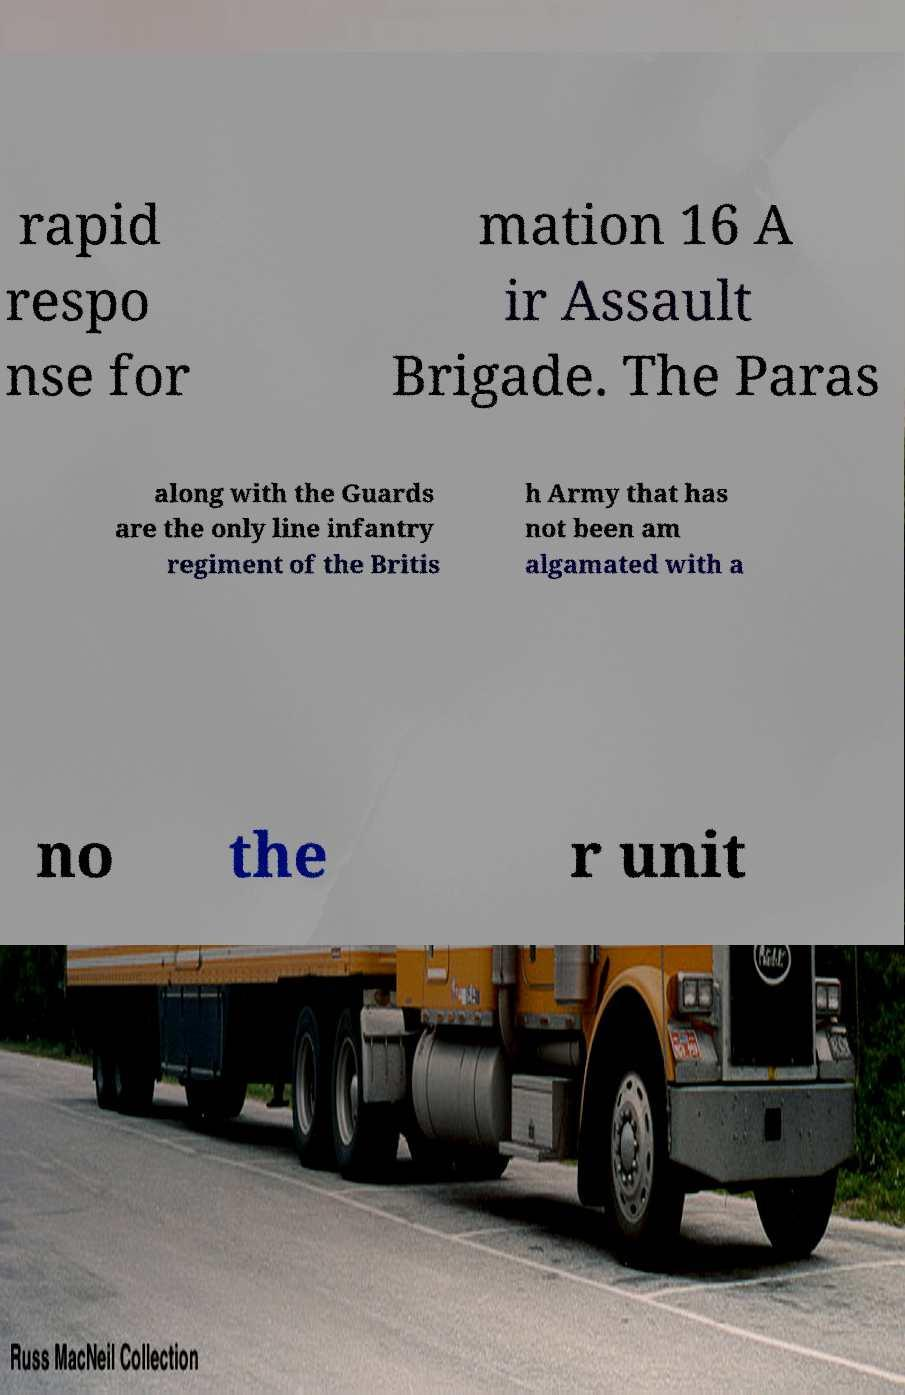Could you assist in decoding the text presented in this image and type it out clearly? rapid respo nse for mation 16 A ir Assault Brigade. The Paras along with the Guards are the only line infantry regiment of the Britis h Army that has not been am algamated with a no the r unit 